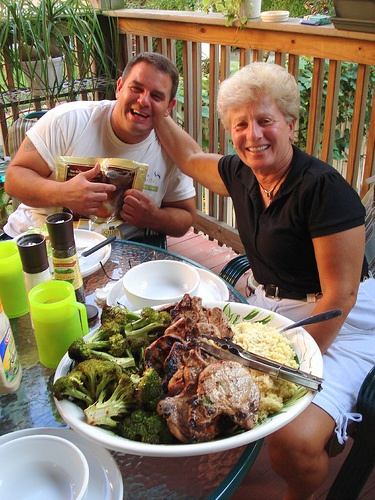Describe the objects in this image and their specific colors. I can see people in olive, black, brown, and maroon tones, bowl in olive, black, white, and maroon tones, people in olive, maroon, brown, lightgray, and darkgray tones, broccoli in olive and black tones, and potted plant in olive, black, darkgreen, and gray tones in this image. 